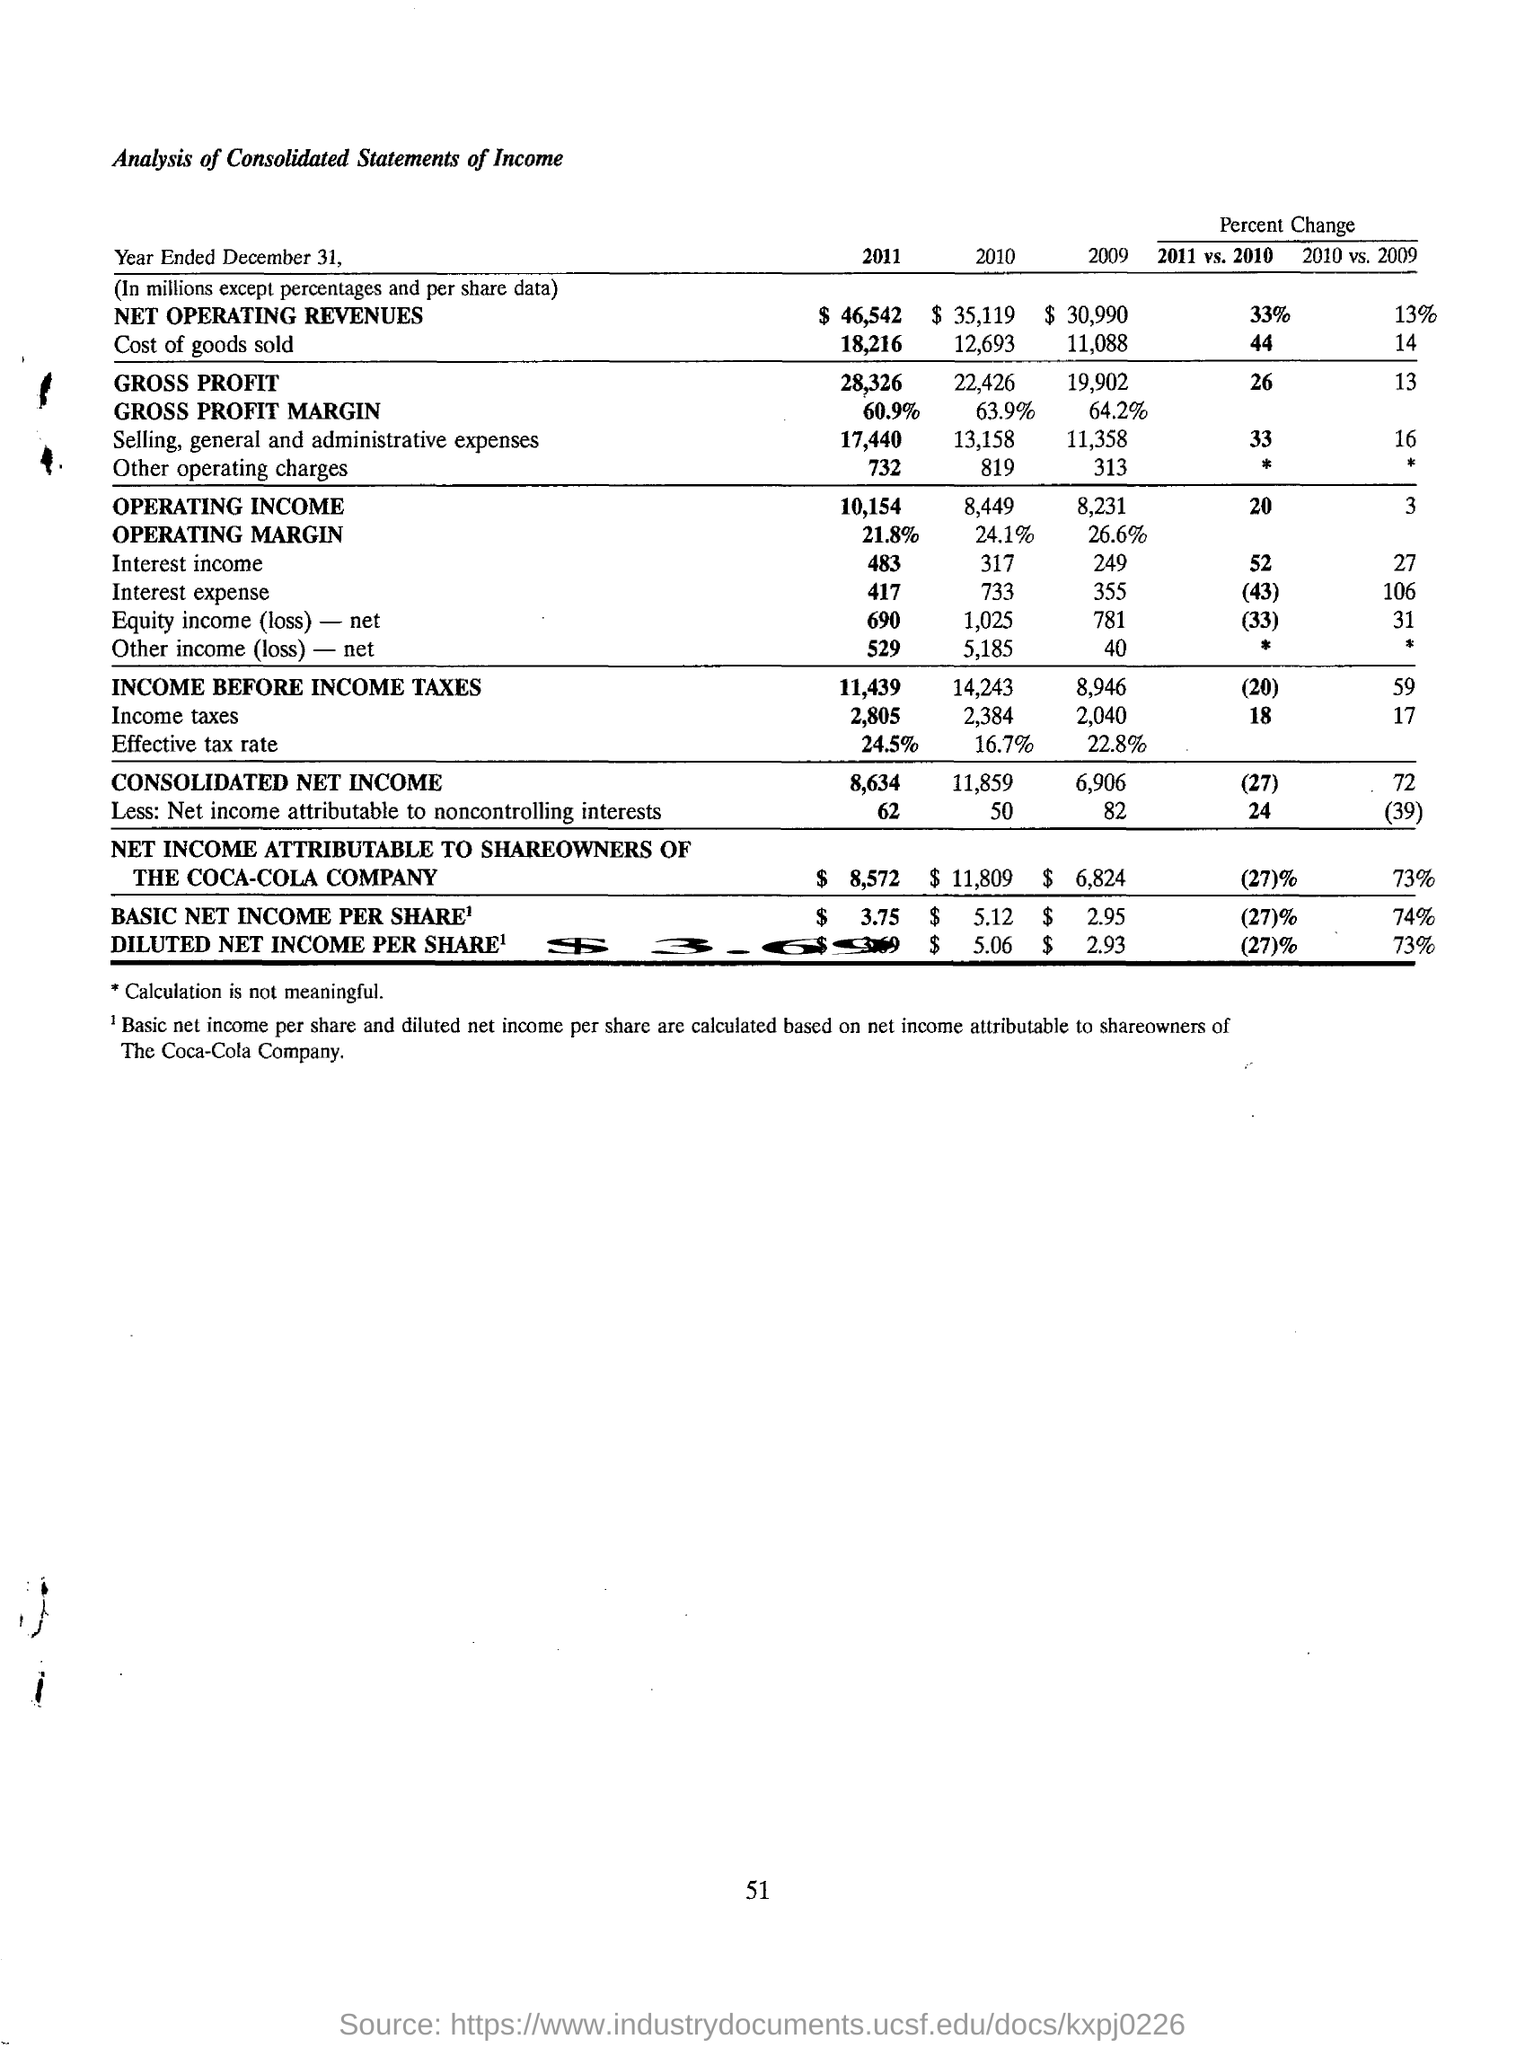List a handful of essential elements in this visual. In the year 2011, the basic net income per share was $3.75. The effective tax rate for the year 2011 was 24.5%. The consolidated net income for the year 2011 was 8,634. The net income attributable to the shareowners of The Coca-Cola Company for the year 2010 was $11,809. The diluted net income per share for the year 2010 was $5.06. 